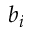<formula> <loc_0><loc_0><loc_500><loc_500>b _ { i }</formula> 